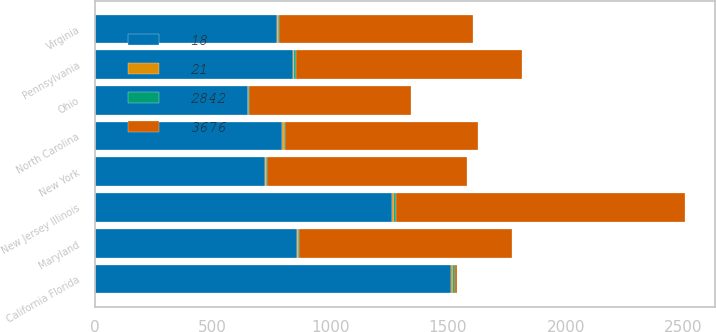<chart> <loc_0><loc_0><loc_500><loc_500><stacked_bar_chart><ecel><fcel>California Florida<fcel>New Jersey Illinois<fcel>Pennsylvania<fcel>Maryland<fcel>New York<fcel>Virginia<fcel>North Carolina<fcel>Ohio<nl><fcel>3676<fcel>10<fcel>1230<fcel>962<fcel>902<fcel>847<fcel>824<fcel>821<fcel>684<nl><fcel>21<fcel>9<fcel>7<fcel>5<fcel>5<fcel>5<fcel>5<fcel>5<fcel>4<nl><fcel>18<fcel>1511<fcel>1263<fcel>843<fcel>857<fcel>722<fcel>772<fcel>797<fcel>649<nl><fcel>2842<fcel>10<fcel>8<fcel>5<fcel>6<fcel>5<fcel>5<fcel>5<fcel>4<nl></chart> 